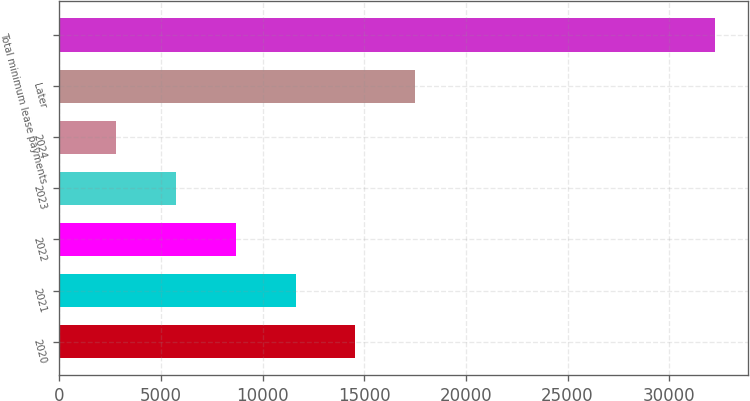<chart> <loc_0><loc_0><loc_500><loc_500><bar_chart><fcel>2020<fcel>2021<fcel>2022<fcel>2023<fcel>2024<fcel>Later<fcel>Total minimum lease payments<nl><fcel>14569.8<fcel>11620.1<fcel>8670.4<fcel>5720.7<fcel>2771<fcel>17519.5<fcel>32268<nl></chart> 